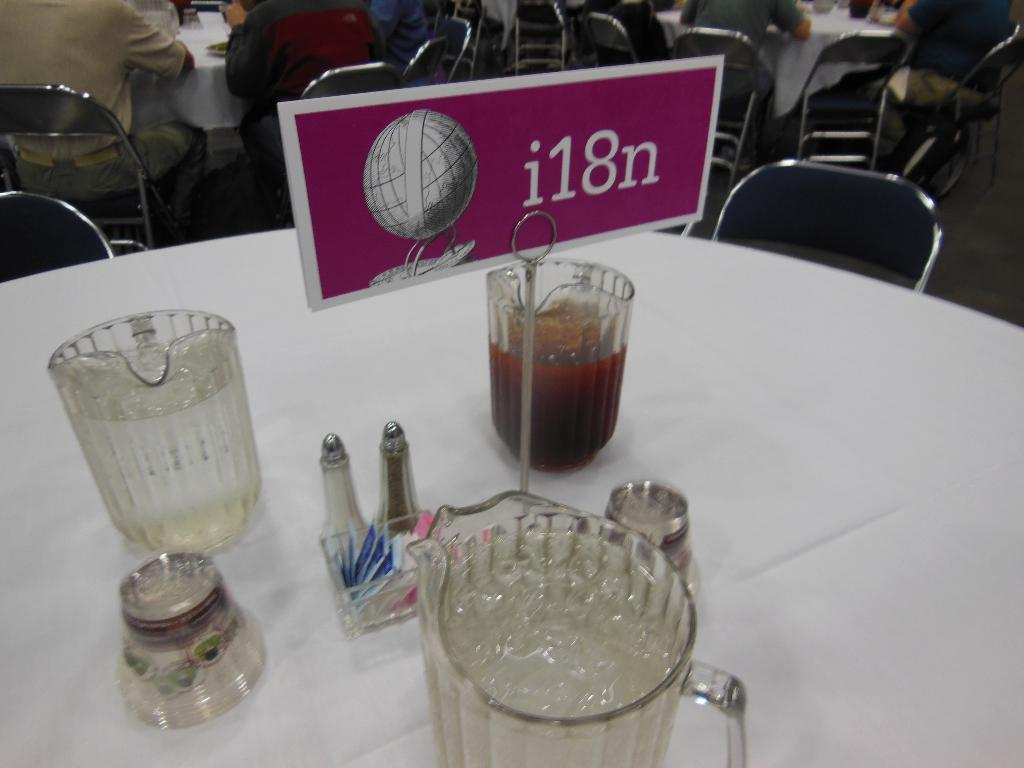<image>
Write a terse but informative summary of the picture. The table placard states the table is reserved for the i18n group. 